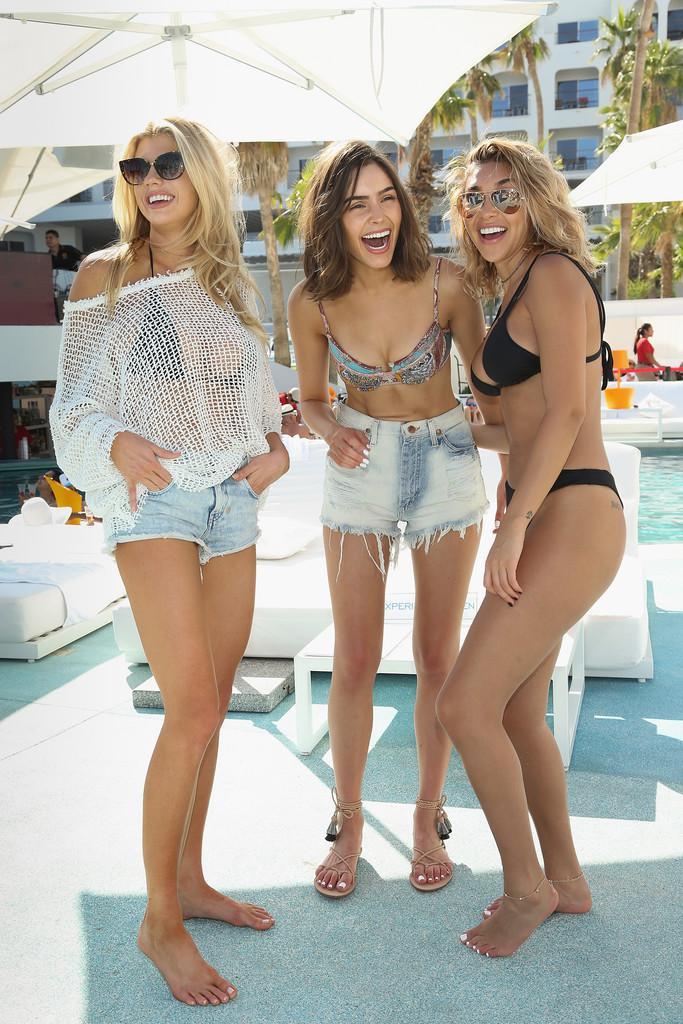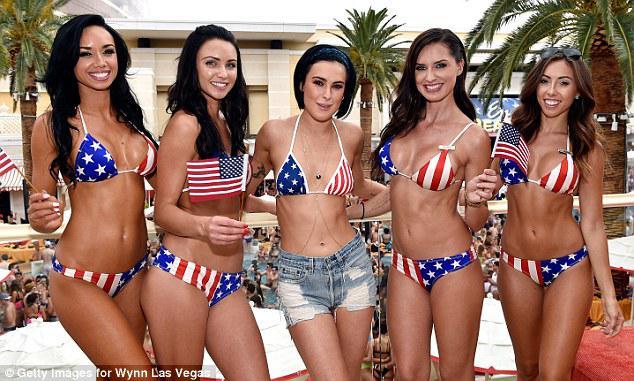The first image is the image on the left, the second image is the image on the right. Given the left and right images, does the statement "A woman is wearing a predominantly orange swimsuit and denim shorts." hold true? Answer yes or no. No. 